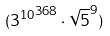Convert formula to latex. <formula><loc_0><loc_0><loc_500><loc_500>( { 3 ^ { 1 0 } } ^ { 3 6 8 } \cdot \sqrt { 5 } ^ { 9 } )</formula> 